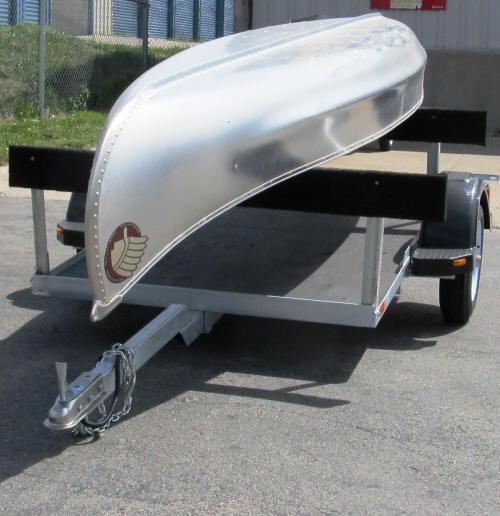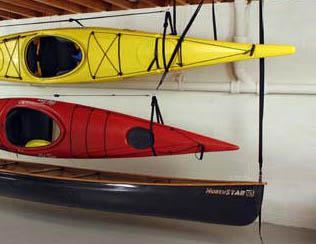The first image is the image on the left, the second image is the image on the right. Given the left and right images, does the statement "There is at least one green canoe visible" hold true? Answer yes or no. No. The first image is the image on the left, the second image is the image on the right. Considering the images on both sides, is "In one image, multiple canoes are on an indoor rack, while in the other image, a single canoe is outside." valid? Answer yes or no. Yes. 